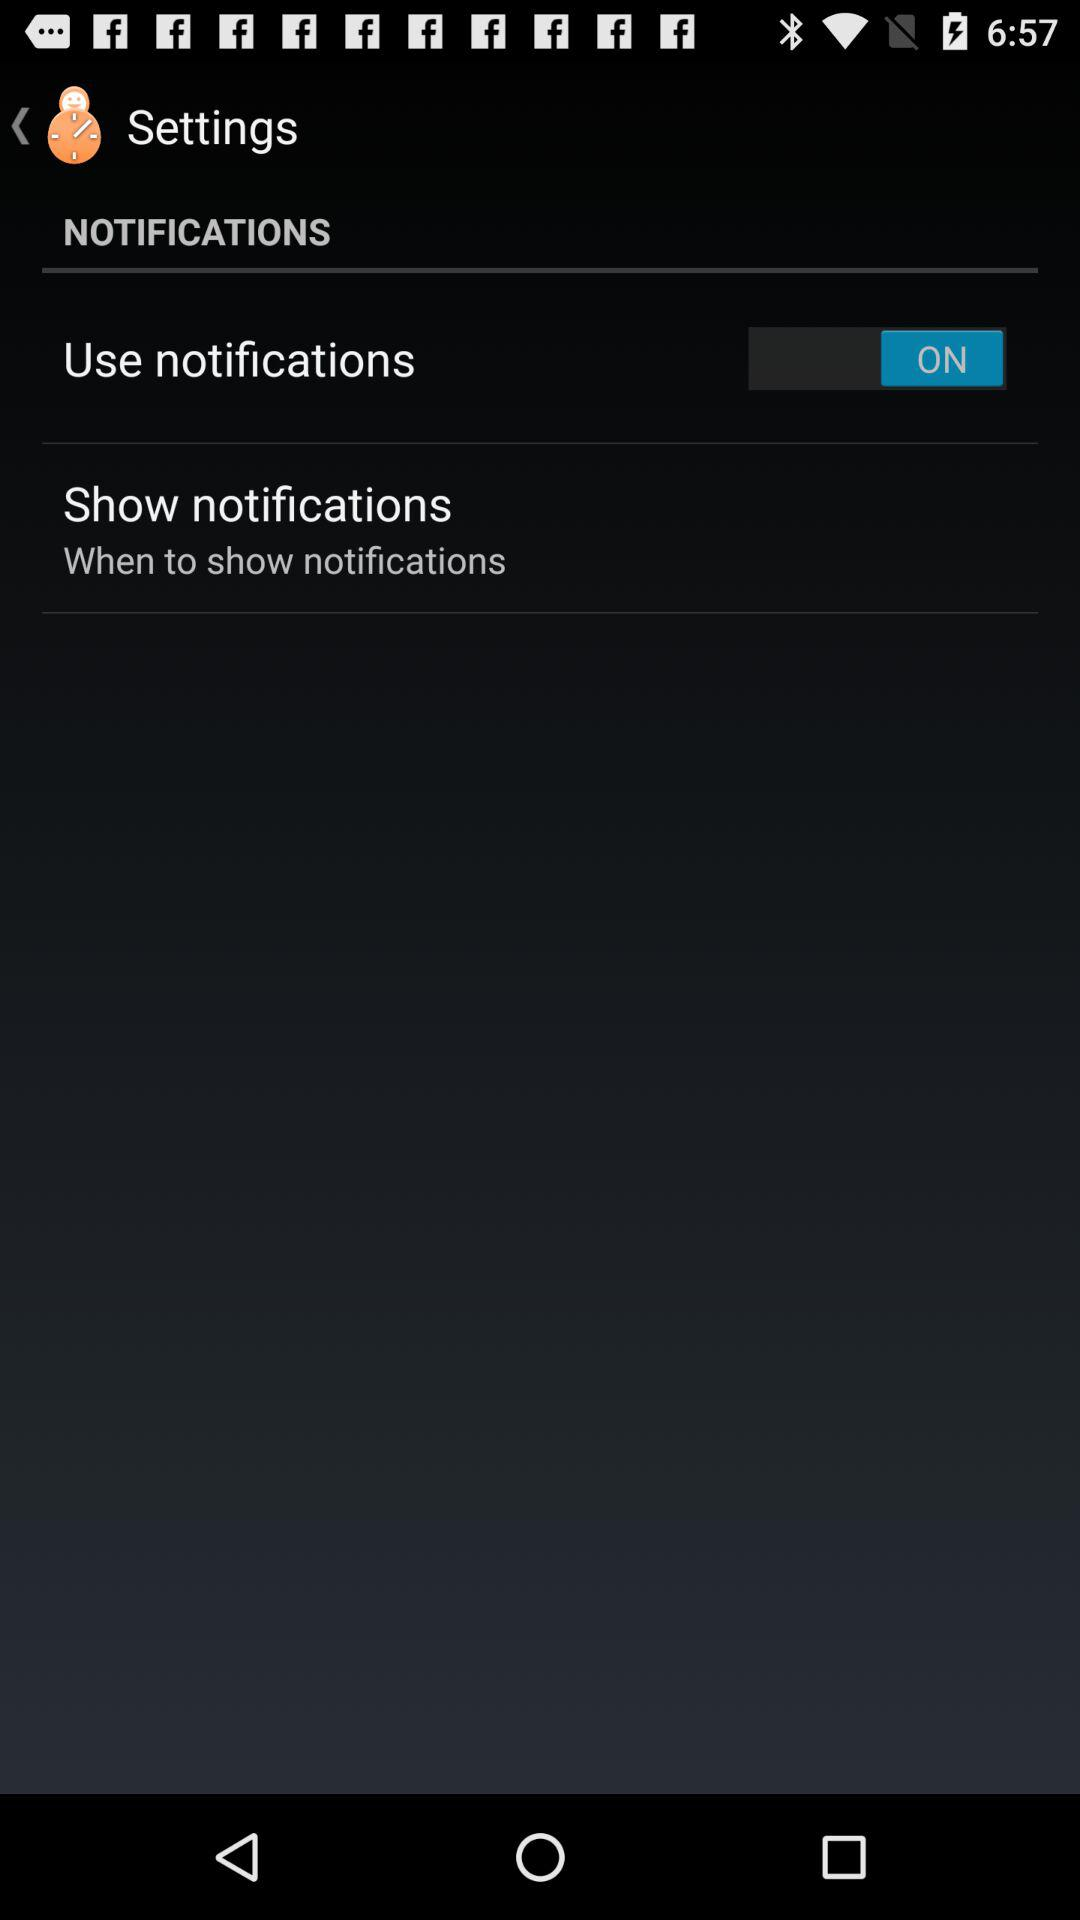What is the status of "Use notifications"? The "Use notifications" status is "ON". 